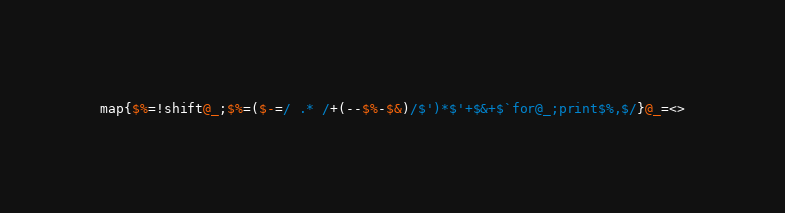<code> <loc_0><loc_0><loc_500><loc_500><_Perl_>map{$%=!shift@_;$%=($-=/ .* /+(--$%-$&)/$')*$'+$&+$`for@_;print$%,$/}@_=<></code> 